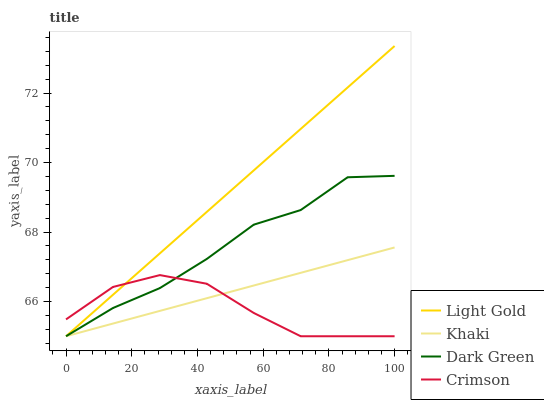Does Crimson have the minimum area under the curve?
Answer yes or no. Yes. Does Light Gold have the maximum area under the curve?
Answer yes or no. Yes. Does Khaki have the minimum area under the curve?
Answer yes or no. No. Does Khaki have the maximum area under the curve?
Answer yes or no. No. Is Khaki the smoothest?
Answer yes or no. Yes. Is Dark Green the roughest?
Answer yes or no. Yes. Is Light Gold the smoothest?
Answer yes or no. No. Is Light Gold the roughest?
Answer yes or no. No. Does Khaki have the highest value?
Answer yes or no. No. 